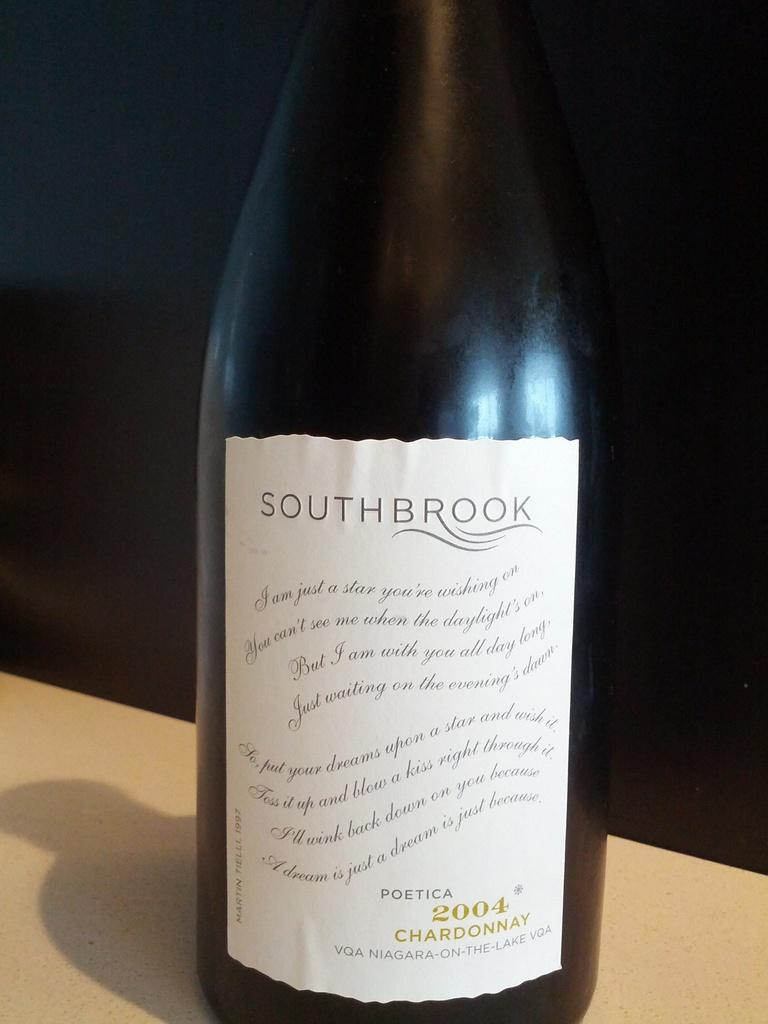<image>
Summarize the visual content of the image. Southbrook Chardonnay Wine made in 2004 from Niagara on the Lake. 